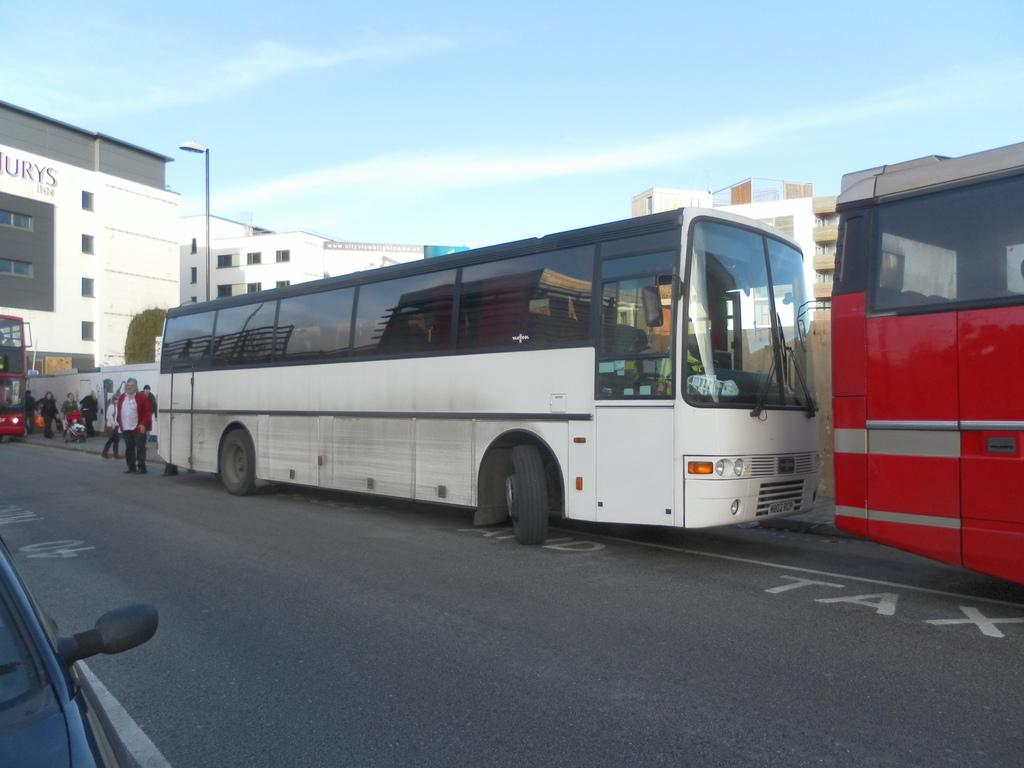What type of structures are present in the image? There are buildings in the image. What feature can be seen on the buildings? There are windows visible in the image. What is the tall, vertical object in the image? There is a light pole in the image. Who or what is present in the image besides the buildings and light pole? There are people and vehicles on the road in the image. What is the color of the sky in the image? The sky is blue and white in color. Where is the ocean visible in the image? There is no ocean present in the image. Who is the mother in the image? There is no mention of a mother in the image. 